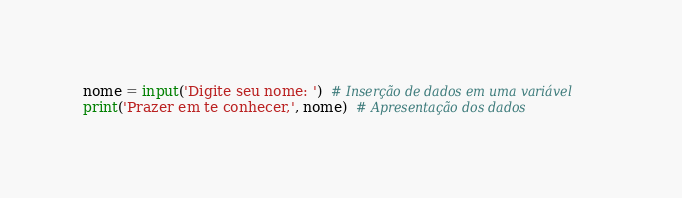Convert code to text. <code><loc_0><loc_0><loc_500><loc_500><_Python_>nome = input('Digite seu nome: ')  # Inserção de dados em uma variável
print('Prazer em te conhecer,', nome)  # Apresentação dos dados
</code> 